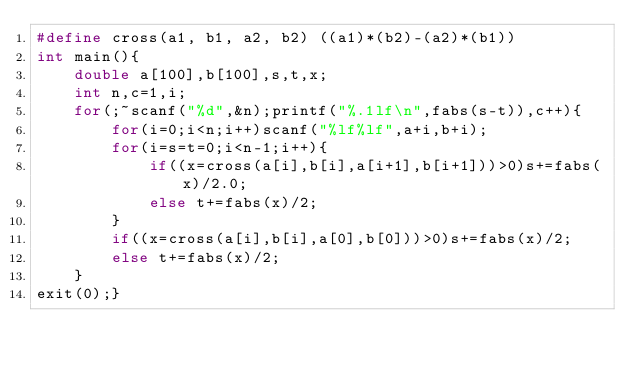<code> <loc_0><loc_0><loc_500><loc_500><_C_>#define cross(a1, b1, a2, b2) ((a1)*(b2)-(a2)*(b1))
int main(){
    double a[100],b[100],s,t,x;
    int n,c=1,i;
    for(;~scanf("%d",&n);printf("%.1lf\n",fabs(s-t)),c++){
        for(i=0;i<n;i++)scanf("%lf%lf",a+i,b+i);
        for(i=s=t=0;i<n-1;i++){
            if((x=cross(a[i],b[i],a[i+1],b[i+1]))>0)s+=fabs(x)/2.0;
            else t+=fabs(x)/2;
        }
        if((x=cross(a[i],b[i],a[0],b[0]))>0)s+=fabs(x)/2;
        else t+=fabs(x)/2;
    }
exit(0);}</code> 